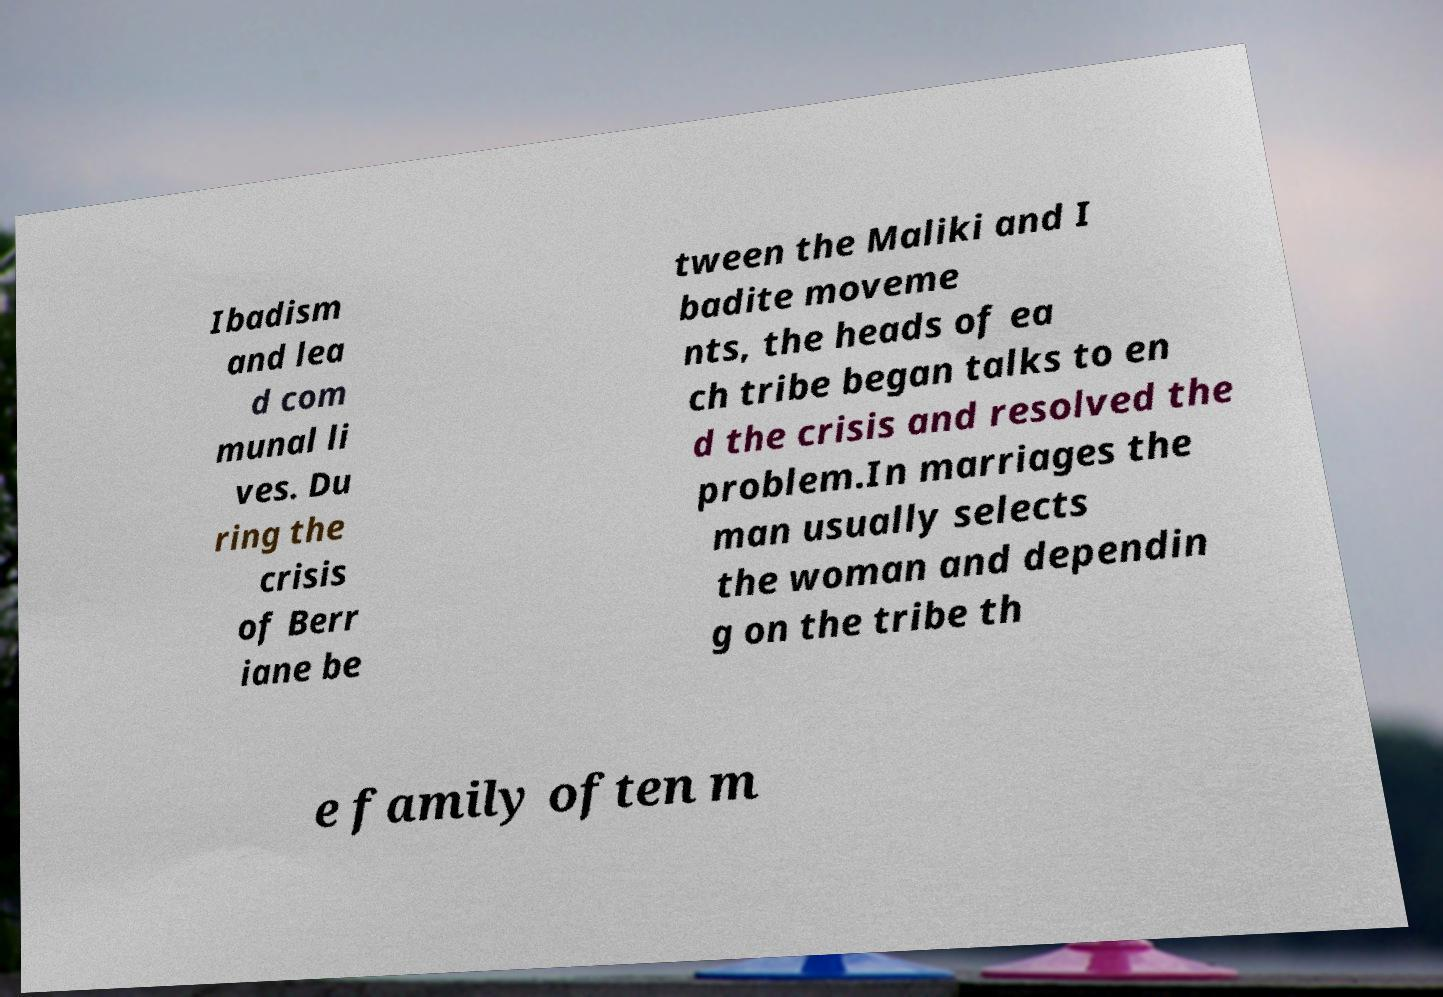Could you extract and type out the text from this image? Ibadism and lea d com munal li ves. Du ring the crisis of Berr iane be tween the Maliki and I badite moveme nts, the heads of ea ch tribe began talks to en d the crisis and resolved the problem.In marriages the man usually selects the woman and dependin g on the tribe th e family often m 